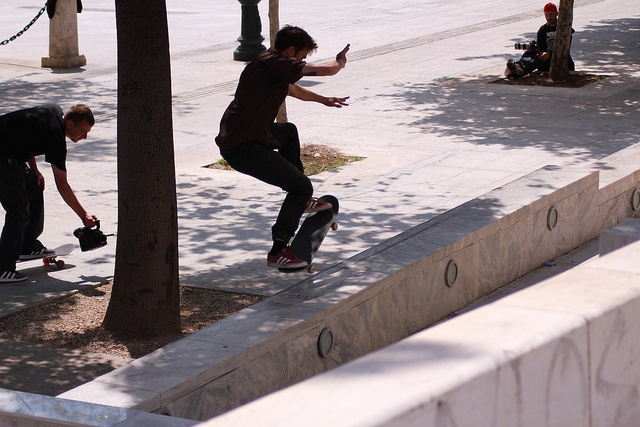Describe the objects in this image and their specific colors. I can see people in lightgray, black, maroon, and gray tones, people in lightgray, black, maroon, and gray tones, people in lightgray, black, maroon, and gray tones, skateboard in lightgray, black, gray, and darkgray tones, and skateboard in lightgray, gray, and black tones in this image. 